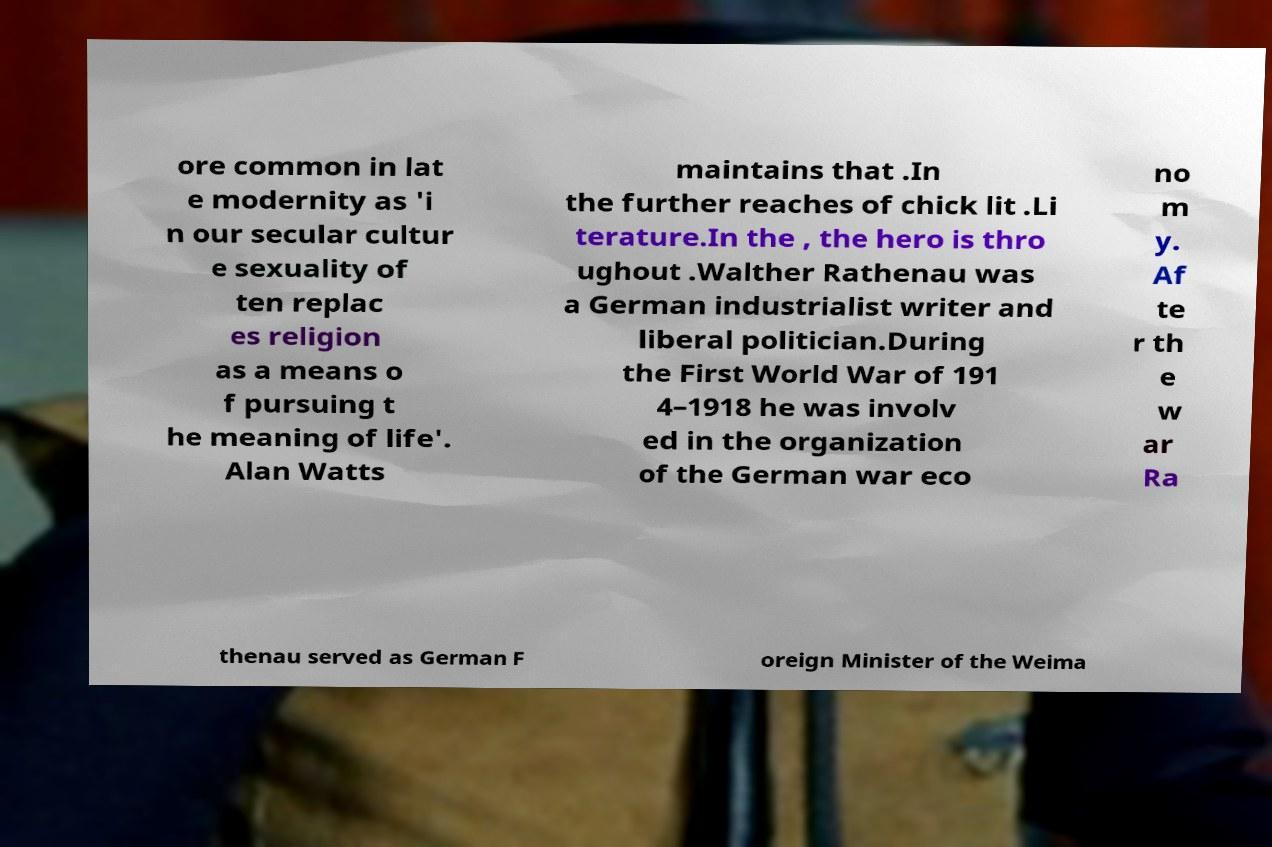I need the written content from this picture converted into text. Can you do that? ore common in lat e modernity as 'i n our secular cultur e sexuality of ten replac es religion as a means o f pursuing t he meaning of life'. Alan Watts maintains that .In the further reaches of chick lit .Li terature.In the , the hero is thro ughout .Walther Rathenau was a German industrialist writer and liberal politician.During the First World War of 191 4–1918 he was involv ed in the organization of the German war eco no m y. Af te r th e w ar Ra thenau served as German F oreign Minister of the Weima 